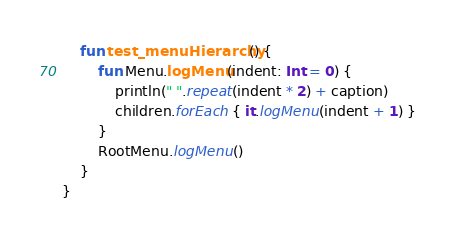Convert code to text. <code><loc_0><loc_0><loc_500><loc_500><_Kotlin_>    fun test_menuHierarchy() {
        fun Menu.logMenu(indent: Int = 0) {
            println(" ".repeat(indent * 2) + caption)
            children.forEach { it.logMenu(indent + 1) }
        }
        RootMenu.logMenu()
    }
}</code> 